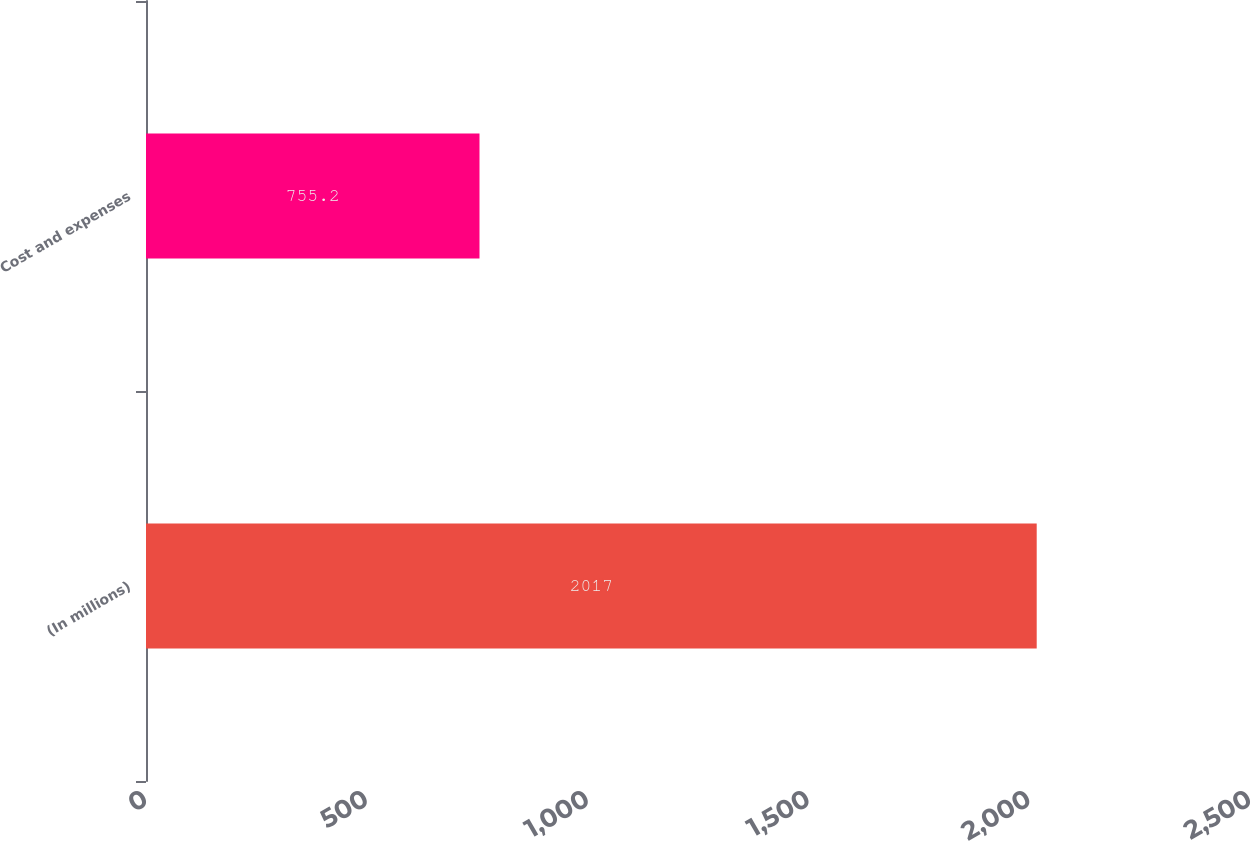Convert chart. <chart><loc_0><loc_0><loc_500><loc_500><bar_chart><fcel>(In millions)<fcel>Cost and expenses<nl><fcel>2017<fcel>755.2<nl></chart> 